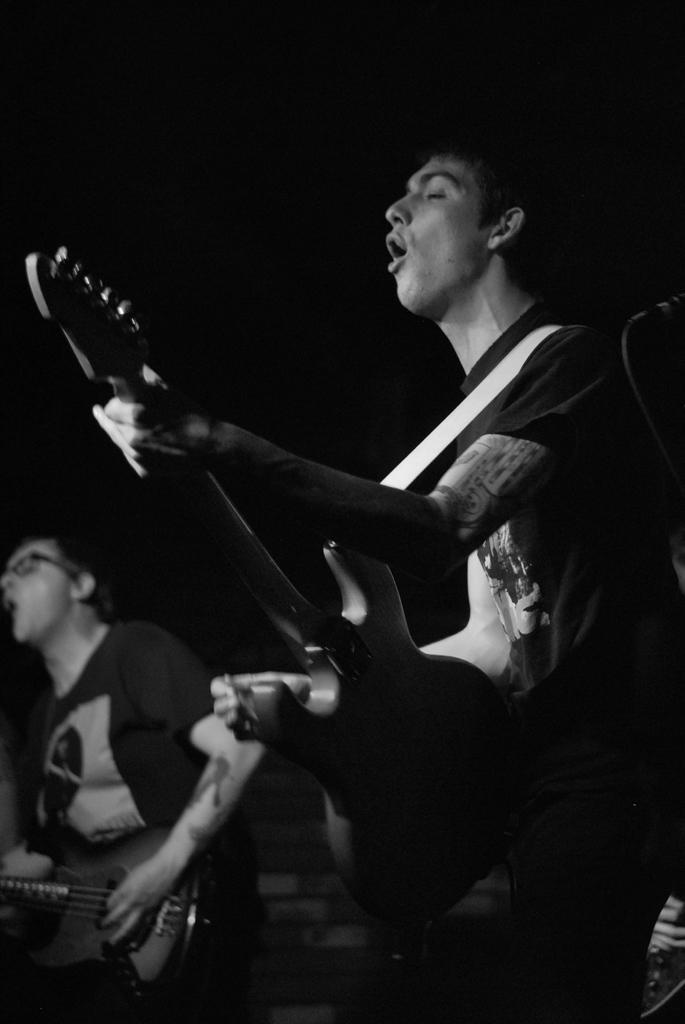Can you describe this image briefly? This is the picture of a man who is holding the guitar and playing it and beside him there is an other person who is holding the guitar. 